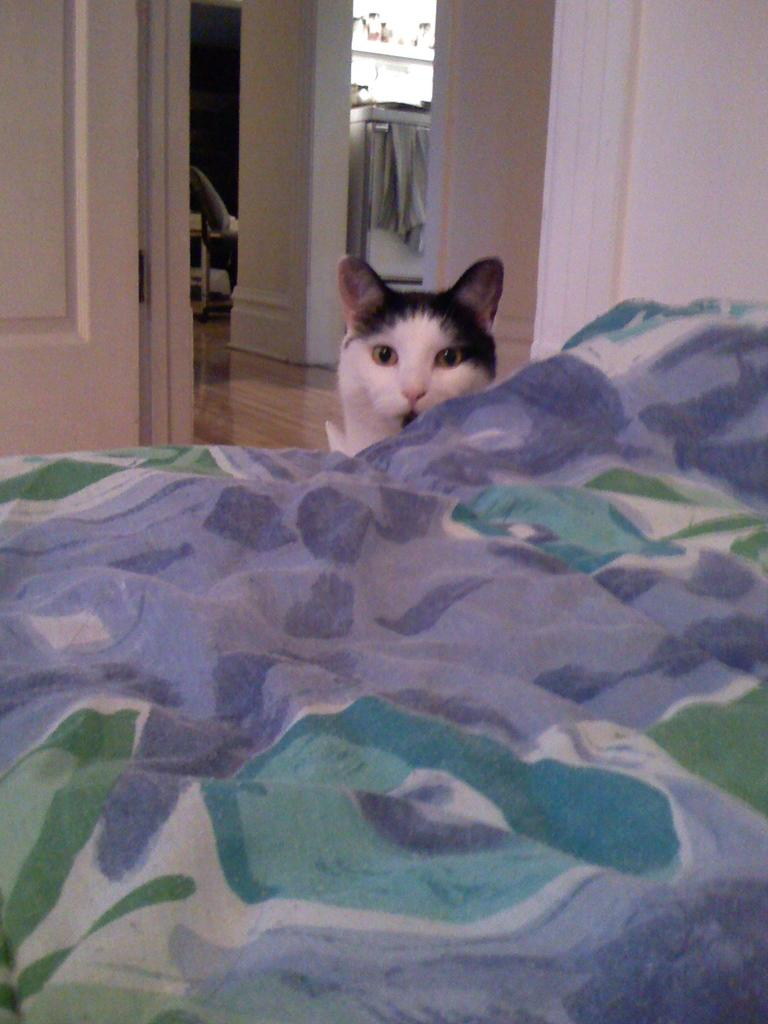What type of furniture is present in the image? There is a bed in the image. What animal can be seen in the image? There is a cat in the image. What is visible in the background of the image? There is a wall in the background of the image. Can you describe the object on the floor in the background of the image? Unfortunately, the facts provided do not give enough information to describe the object on the floor in the background. What type of cake is being served to the flock of animals in the image? There is no cake or flock of animals present in the image. What disease is the cat suffering from in the image? The facts provided do not give any information about the cat's health, so it is impossible to determine if the cat is suffering from any disease. 